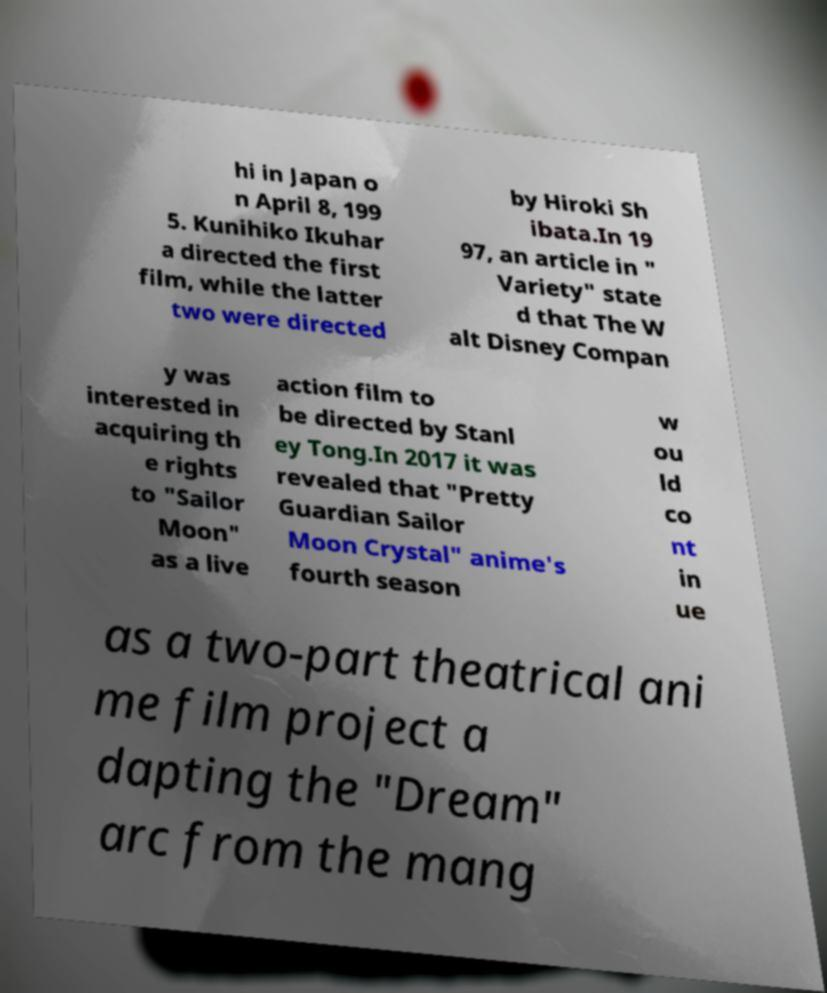For documentation purposes, I need the text within this image transcribed. Could you provide that? hi in Japan o n April 8, 199 5. Kunihiko Ikuhar a directed the first film, while the latter two were directed by Hiroki Sh ibata.In 19 97, an article in " Variety" state d that The W alt Disney Compan y was interested in acquiring th e rights to "Sailor Moon" as a live action film to be directed by Stanl ey Tong.In 2017 it was revealed that "Pretty Guardian Sailor Moon Crystal" anime's fourth season w ou ld co nt in ue as a two-part theatrical ani me film project a dapting the "Dream" arc from the mang 